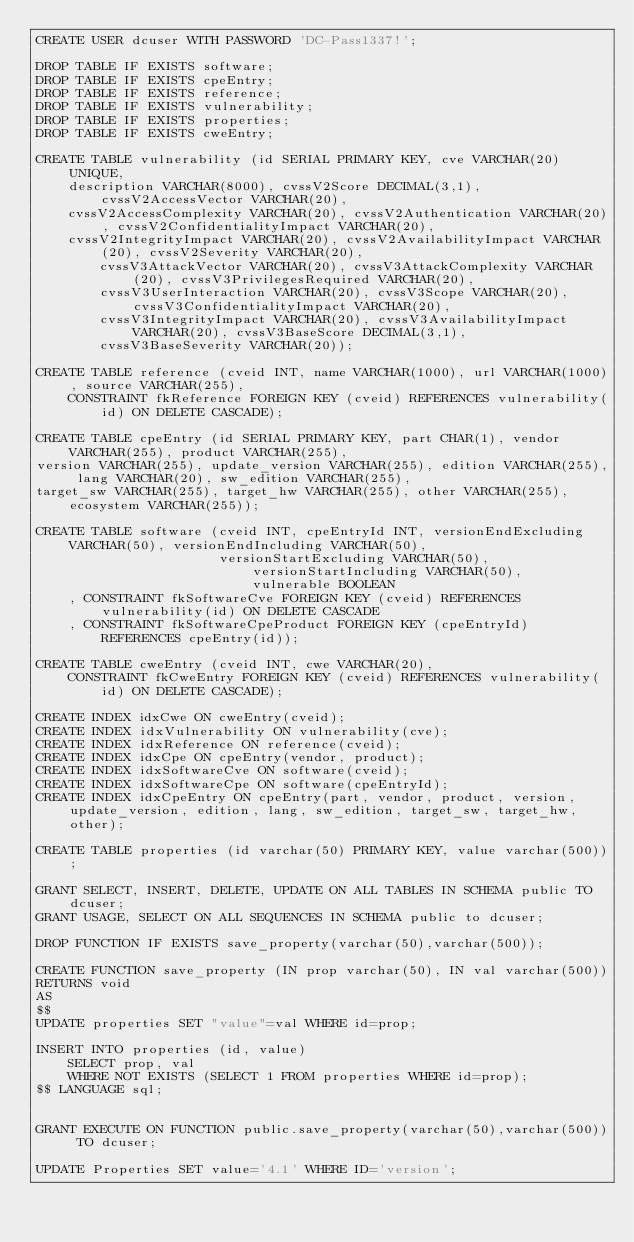<code> <loc_0><loc_0><loc_500><loc_500><_SQL_>CREATE USER dcuser WITH PASSWORD 'DC-Pass1337!';

DROP TABLE IF EXISTS software;
DROP TABLE IF EXISTS cpeEntry;
DROP TABLE IF EXISTS reference;
DROP TABLE IF EXISTS vulnerability;
DROP TABLE IF EXISTS properties;
DROP TABLE IF EXISTS cweEntry;

CREATE TABLE vulnerability (id SERIAL PRIMARY KEY, cve VARCHAR(20) UNIQUE,
	description VARCHAR(8000), cvssV2Score DECIMAL(3,1), cvssV2AccessVector VARCHAR(20),
	cvssV2AccessComplexity VARCHAR(20), cvssV2Authentication VARCHAR(20), cvssV2ConfidentialityImpact VARCHAR(20),
	cvssV2IntegrityImpact VARCHAR(20), cvssV2AvailabilityImpact VARCHAR(20), cvssV2Severity VARCHAR(20),
        cvssV3AttackVector VARCHAR(20), cvssV3AttackComplexity VARCHAR(20), cvssV3PrivilegesRequired VARCHAR(20),
        cvssV3UserInteraction VARCHAR(20), cvssV3Scope VARCHAR(20), cvssV3ConfidentialityImpact VARCHAR(20),
        cvssV3IntegrityImpact VARCHAR(20), cvssV3AvailabilityImpact VARCHAR(20), cvssV3BaseScore DECIMAL(3,1), 
        cvssV3BaseSeverity VARCHAR(20));

CREATE TABLE reference (cveid INT, name VARCHAR(1000), url VARCHAR(1000), source VARCHAR(255),
	CONSTRAINT fkReference FOREIGN KEY (cveid) REFERENCES vulnerability(id) ON DELETE CASCADE);

CREATE TABLE cpeEntry (id SERIAL PRIMARY KEY, part CHAR(1), vendor VARCHAR(255), product VARCHAR(255),
version VARCHAR(255), update_version VARCHAR(255), edition VARCHAR(255), lang VARCHAR(20), sw_edition VARCHAR(255), 
target_sw VARCHAR(255), target_hw VARCHAR(255), other VARCHAR(255), ecosystem VARCHAR(255));

CREATE TABLE software (cveid INT, cpeEntryId INT, versionEndExcluding VARCHAR(50), versionEndIncluding VARCHAR(50), 
                       versionStartExcluding VARCHAR(50), versionStartIncluding VARCHAR(50), vulnerable BOOLEAN
    , CONSTRAINT fkSoftwareCve FOREIGN KEY (cveid) REFERENCES vulnerability(id) ON DELETE CASCADE
    , CONSTRAINT fkSoftwareCpeProduct FOREIGN KEY (cpeEntryId) REFERENCES cpeEntry(id));

CREATE TABLE cweEntry (cveid INT, cwe VARCHAR(20),
    CONSTRAINT fkCweEntry FOREIGN KEY (cveid) REFERENCES vulnerability(id) ON DELETE CASCADE);

CREATE INDEX idxCwe ON cweEntry(cveid);
CREATE INDEX idxVulnerability ON vulnerability(cve);
CREATE INDEX idxReference ON reference(cveid);
CREATE INDEX idxCpe ON cpeEntry(vendor, product);
CREATE INDEX idxSoftwareCve ON software(cveid);
CREATE INDEX idxSoftwareCpe ON software(cpeEntryId);
CREATE INDEX idxCpeEntry ON cpeEntry(part, vendor, product, version, update_version, edition, lang, sw_edition, target_sw, target_hw, other);

CREATE TABLE properties (id varchar(50) PRIMARY KEY, value varchar(500));

GRANT SELECT, INSERT, DELETE, UPDATE ON ALL TABLES IN SCHEMA public TO dcuser;
GRANT USAGE, SELECT ON ALL SEQUENCES IN SCHEMA public to dcuser;

DROP FUNCTION IF EXISTS save_property(varchar(50),varchar(500));

CREATE FUNCTION save_property (IN prop varchar(50), IN val varchar(500))
RETURNS void
AS
$$
UPDATE properties SET "value"=val WHERE id=prop;

INSERT INTO properties (id, value)
	SELECT prop, val
	WHERE NOT EXISTS (SELECT 1 FROM properties WHERE id=prop);
$$ LANGUAGE sql;


GRANT EXECUTE ON FUNCTION public.save_property(varchar(50),varchar(500)) TO dcuser;

UPDATE Properties SET value='4.1' WHERE ID='version';
</code> 